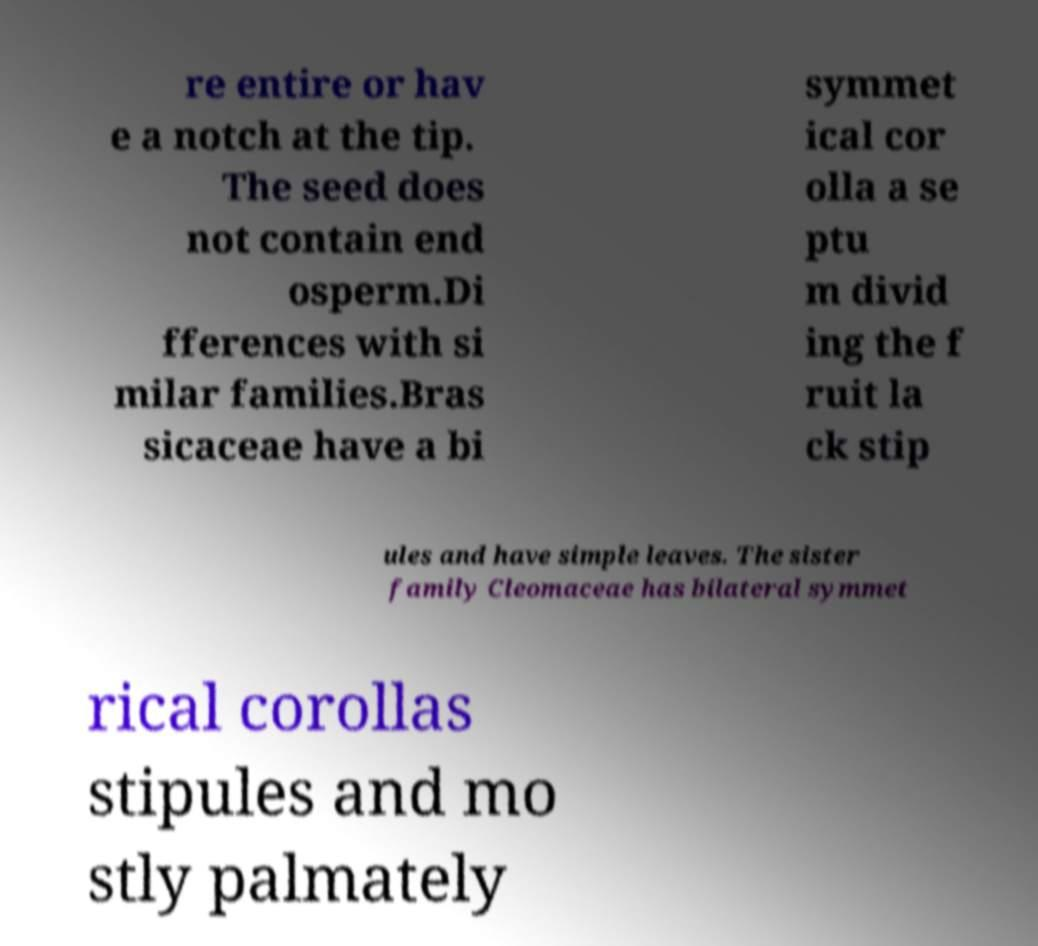Could you assist in decoding the text presented in this image and type it out clearly? re entire or hav e a notch at the tip. The seed does not contain end osperm.Di fferences with si milar families.Bras sicaceae have a bi symmet ical cor olla a se ptu m divid ing the f ruit la ck stip ules and have simple leaves. The sister family Cleomaceae has bilateral symmet rical corollas stipules and mo stly palmately 